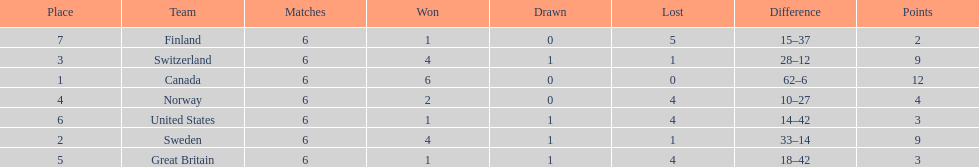How many teams won at least 4 matches? 3. 